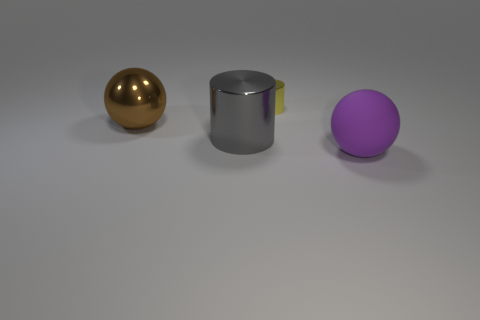Add 3 blue matte blocks. How many objects exist? 7 Subtract all large matte objects. Subtract all large cylinders. How many objects are left? 2 Add 4 gray cylinders. How many gray cylinders are left? 5 Add 1 brown spheres. How many brown spheres exist? 2 Subtract 0 cyan cylinders. How many objects are left? 4 